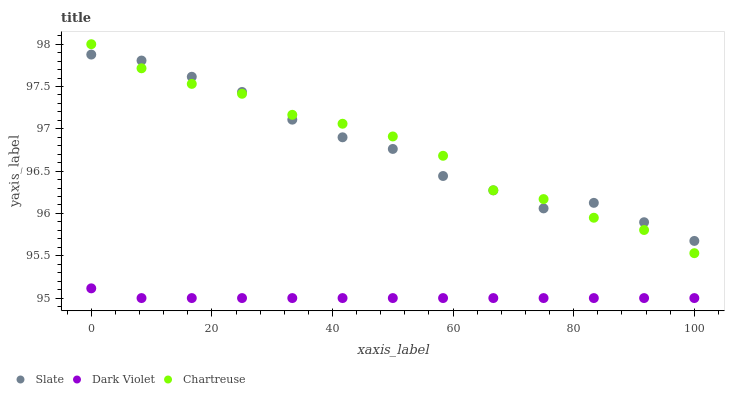Does Dark Violet have the minimum area under the curve?
Answer yes or no. Yes. Does Chartreuse have the maximum area under the curve?
Answer yes or no. Yes. Does Chartreuse have the minimum area under the curve?
Answer yes or no. No. Does Dark Violet have the maximum area under the curve?
Answer yes or no. No. Is Dark Violet the smoothest?
Answer yes or no. Yes. Is Slate the roughest?
Answer yes or no. Yes. Is Chartreuse the smoothest?
Answer yes or no. No. Is Chartreuse the roughest?
Answer yes or no. No. Does Dark Violet have the lowest value?
Answer yes or no. Yes. Does Chartreuse have the lowest value?
Answer yes or no. No. Does Chartreuse have the highest value?
Answer yes or no. Yes. Does Dark Violet have the highest value?
Answer yes or no. No. Is Dark Violet less than Chartreuse?
Answer yes or no. Yes. Is Slate greater than Dark Violet?
Answer yes or no. Yes. Does Chartreuse intersect Slate?
Answer yes or no. Yes. Is Chartreuse less than Slate?
Answer yes or no. No. Is Chartreuse greater than Slate?
Answer yes or no. No. Does Dark Violet intersect Chartreuse?
Answer yes or no. No. 